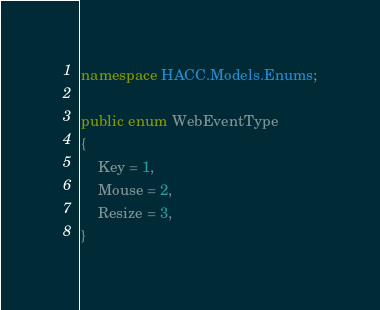<code> <loc_0><loc_0><loc_500><loc_500><_C#_>namespace HACC.Models.Enums;

public enum WebEventType
{
    Key = 1,
    Mouse = 2,
    Resize = 3,
}</code> 